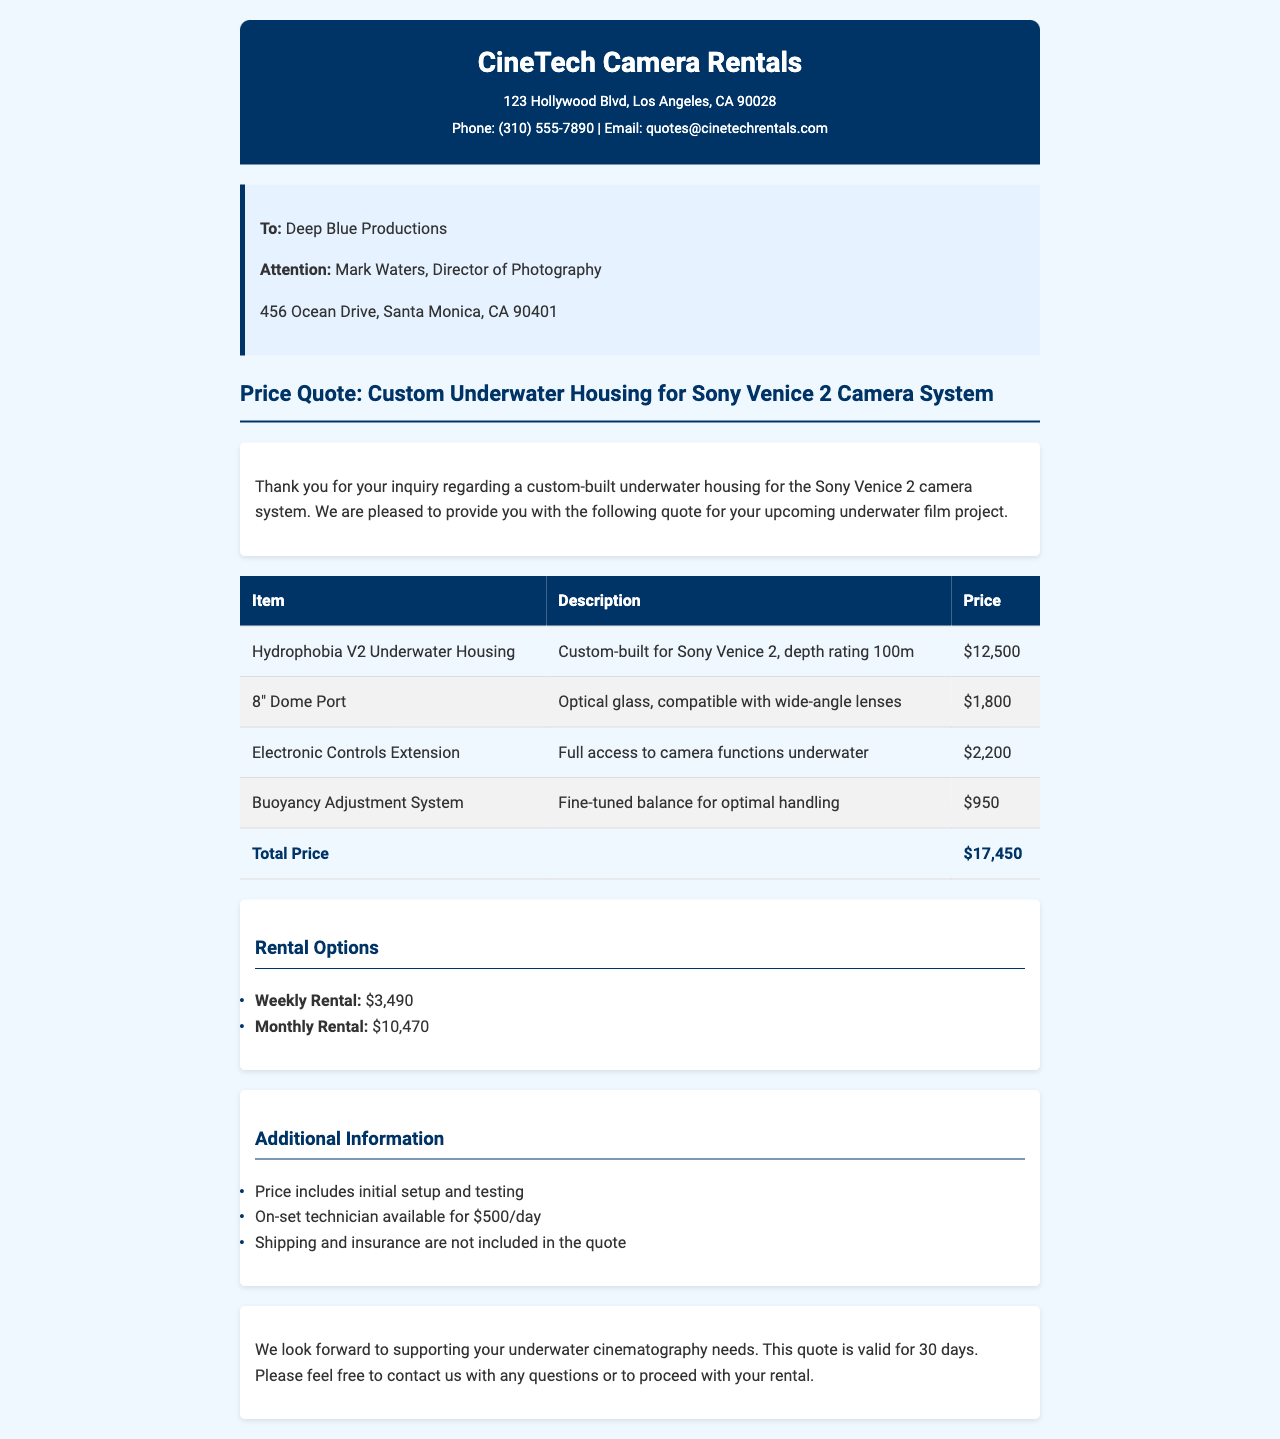What is the total price for the underwater housing? The total price is provided in the table under "Total Price" which sums up the cost of all items.
Answer: $17,450 Who is the recipient of the quote? The recipient is mentioned in the "To:" section of the document.
Answer: Deep Blue Productions What is the cost of the 8" Dome Port? The price for the 8" Dome Port is listed in the table under its corresponding item.
Answer: $1,800 What is the rental price for a monthly option? The monthly rental price is stated in the "Rental Options" section of the document.
Answer: $10,470 How long is the quote valid for? The duration of the quote validity is mentioned in the closing paragraph of the document.
Answer: 30 days What is the role of Mark Waters? Mark Waters is specified in the "Attention:" line of the recipient section.
Answer: Director of Photography What is included in the price? The additional information section lists what's included in the price provided in the quote.
Answer: Initial setup and testing How much does an on-set technician cost per day? The cost of an on-set technician is stated in the additional information section.
Answer: $500/day 